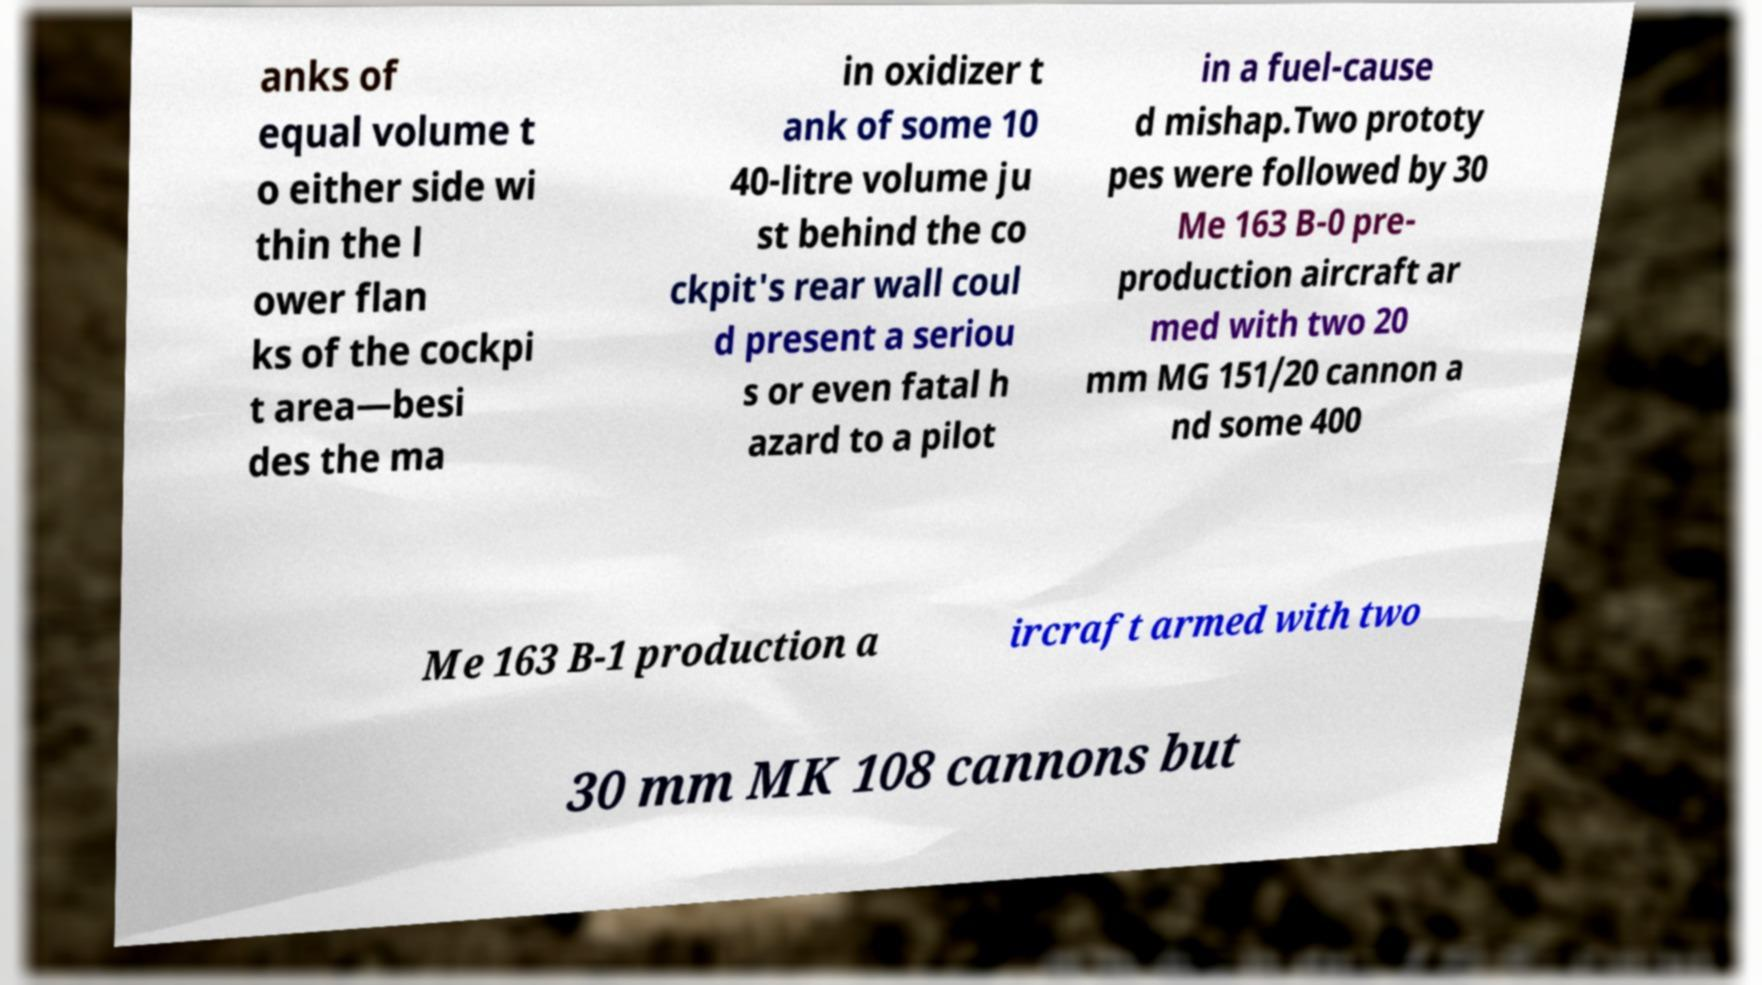Could you extract and type out the text from this image? anks of equal volume t o either side wi thin the l ower flan ks of the cockpi t area—besi des the ma in oxidizer t ank of some 10 40-litre volume ju st behind the co ckpit's rear wall coul d present a seriou s or even fatal h azard to a pilot in a fuel-cause d mishap.Two prototy pes were followed by 30 Me 163 B-0 pre- production aircraft ar med with two 20 mm MG 151/20 cannon a nd some 400 Me 163 B-1 production a ircraft armed with two 30 mm MK 108 cannons but 